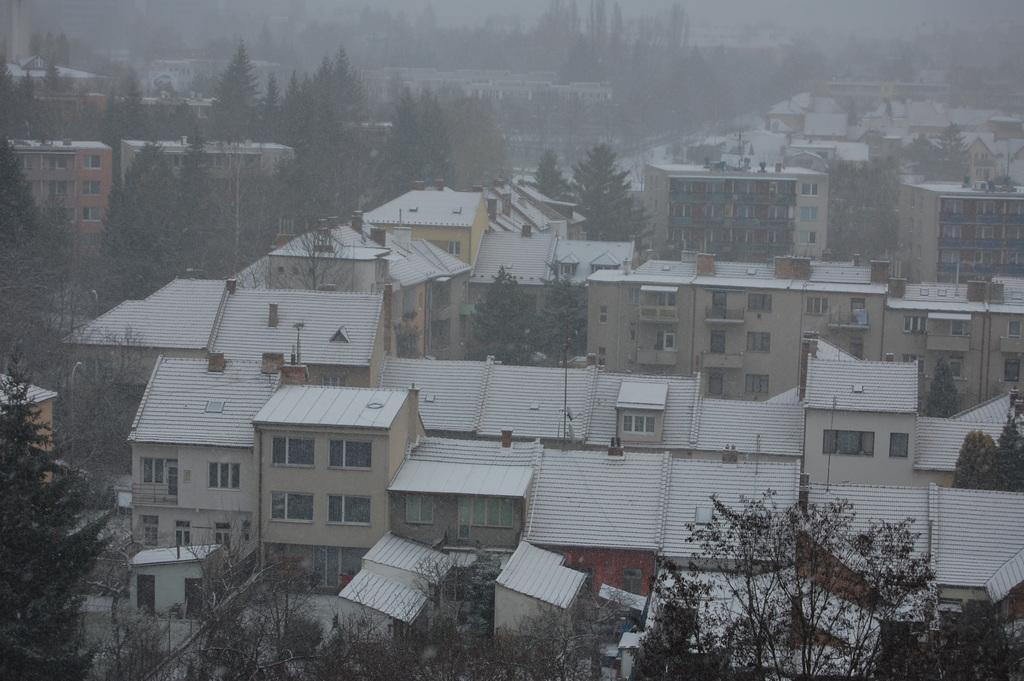Could you give a brief overview of what you see in this image? This image contains few buildings having few trees in between them. 